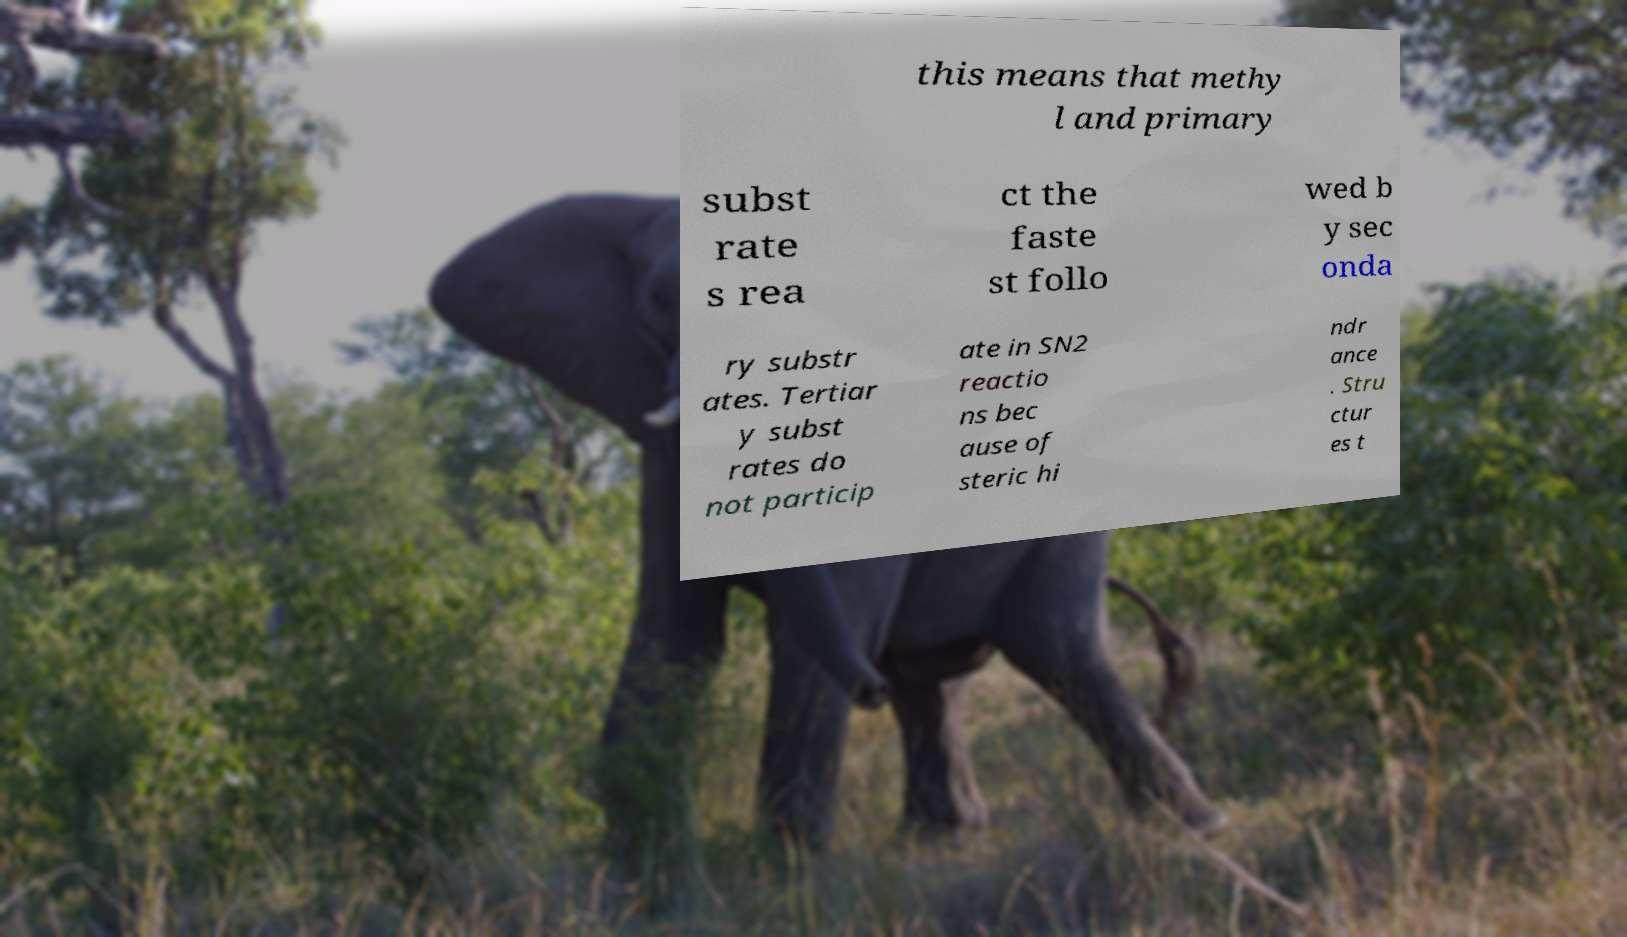Please read and relay the text visible in this image. What does it say? this means that methy l and primary subst rate s rea ct the faste st follo wed b y sec onda ry substr ates. Tertiar y subst rates do not particip ate in SN2 reactio ns bec ause of steric hi ndr ance . Stru ctur es t 